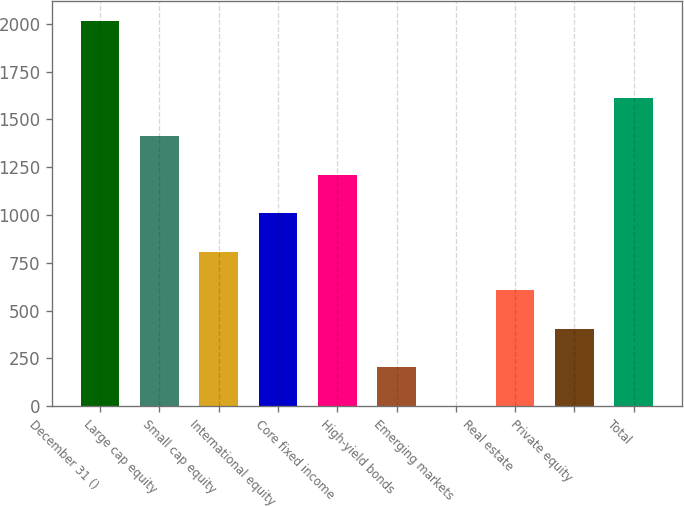<chart> <loc_0><loc_0><loc_500><loc_500><bar_chart><fcel>December 31 ()<fcel>Large cap equity<fcel>Small cap equity<fcel>International equity<fcel>Core fixed income<fcel>High-yield bonds<fcel>Emerging markets<fcel>Real estate<fcel>Private equity<fcel>Total<nl><fcel>2016<fcel>1411.8<fcel>807.6<fcel>1009<fcel>1210.4<fcel>203.4<fcel>2<fcel>606.2<fcel>404.8<fcel>1613.2<nl></chart> 